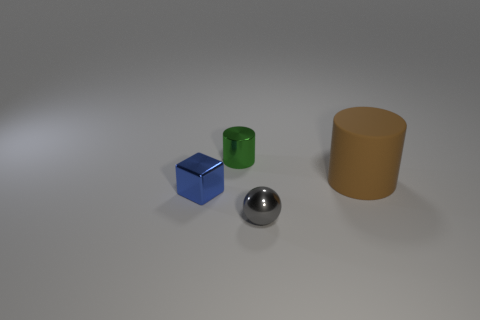How many tiny objects are made of the same material as the small cylinder?
Make the answer very short. 2. There is a gray metallic object; does it have the same shape as the small metal object that is behind the small blue shiny block?
Ensure brevity in your answer.  No. There is a metal object that is in front of the metal object that is to the left of the small metallic cylinder; are there any small cubes on the left side of it?
Your response must be concise. Yes. There is a thing in front of the small blue metal object; how big is it?
Ensure brevity in your answer.  Small. What is the material of the block that is the same size as the gray thing?
Keep it short and to the point. Metal. Is the large brown rubber object the same shape as the small green metallic thing?
Make the answer very short. Yes. What number of things are big blue rubber cubes or objects that are on the right side of the gray metal thing?
Your response must be concise. 1. There is a object in front of the blue metallic cube; is it the same size as the large brown thing?
Offer a very short reply. No. There is a cylinder behind the cylinder that is in front of the tiny cylinder; what number of rubber cylinders are on the left side of it?
Provide a short and direct response. 0. What number of purple things are either big matte cylinders or metal objects?
Ensure brevity in your answer.  0. 